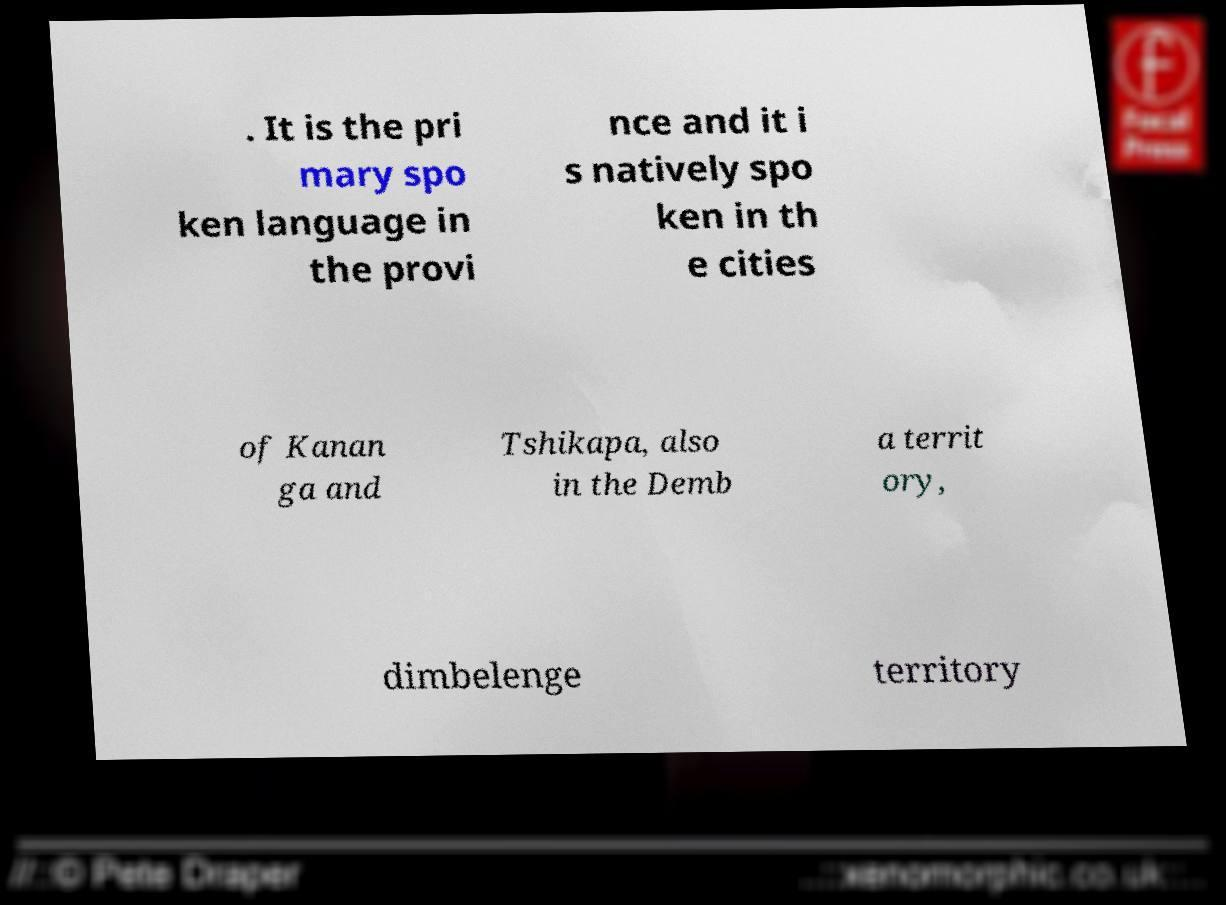Can you read and provide the text displayed in the image?This photo seems to have some interesting text. Can you extract and type it out for me? . It is the pri mary spo ken language in the provi nce and it i s natively spo ken in th e cities of Kanan ga and Tshikapa, also in the Demb a territ ory, dimbelenge territory 